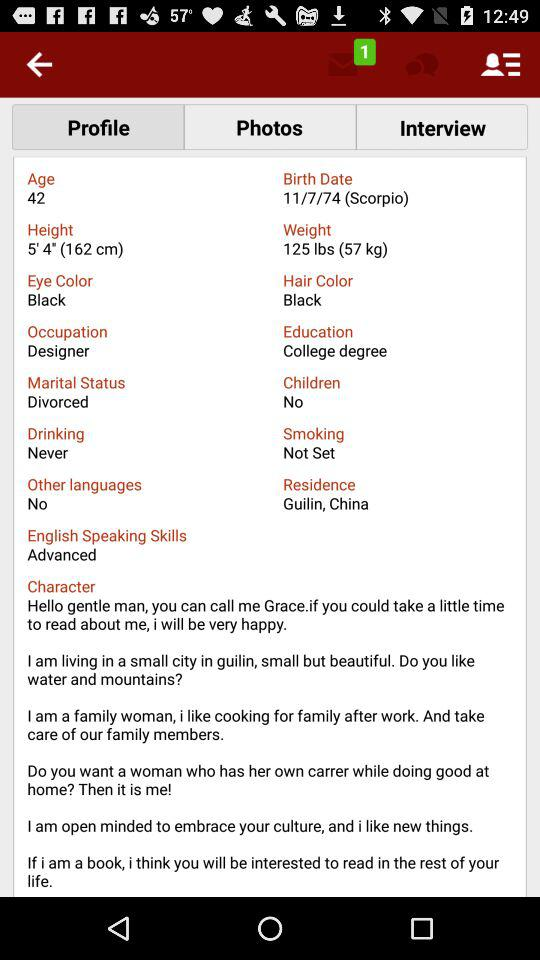What is the hair color? The hair color is black. 